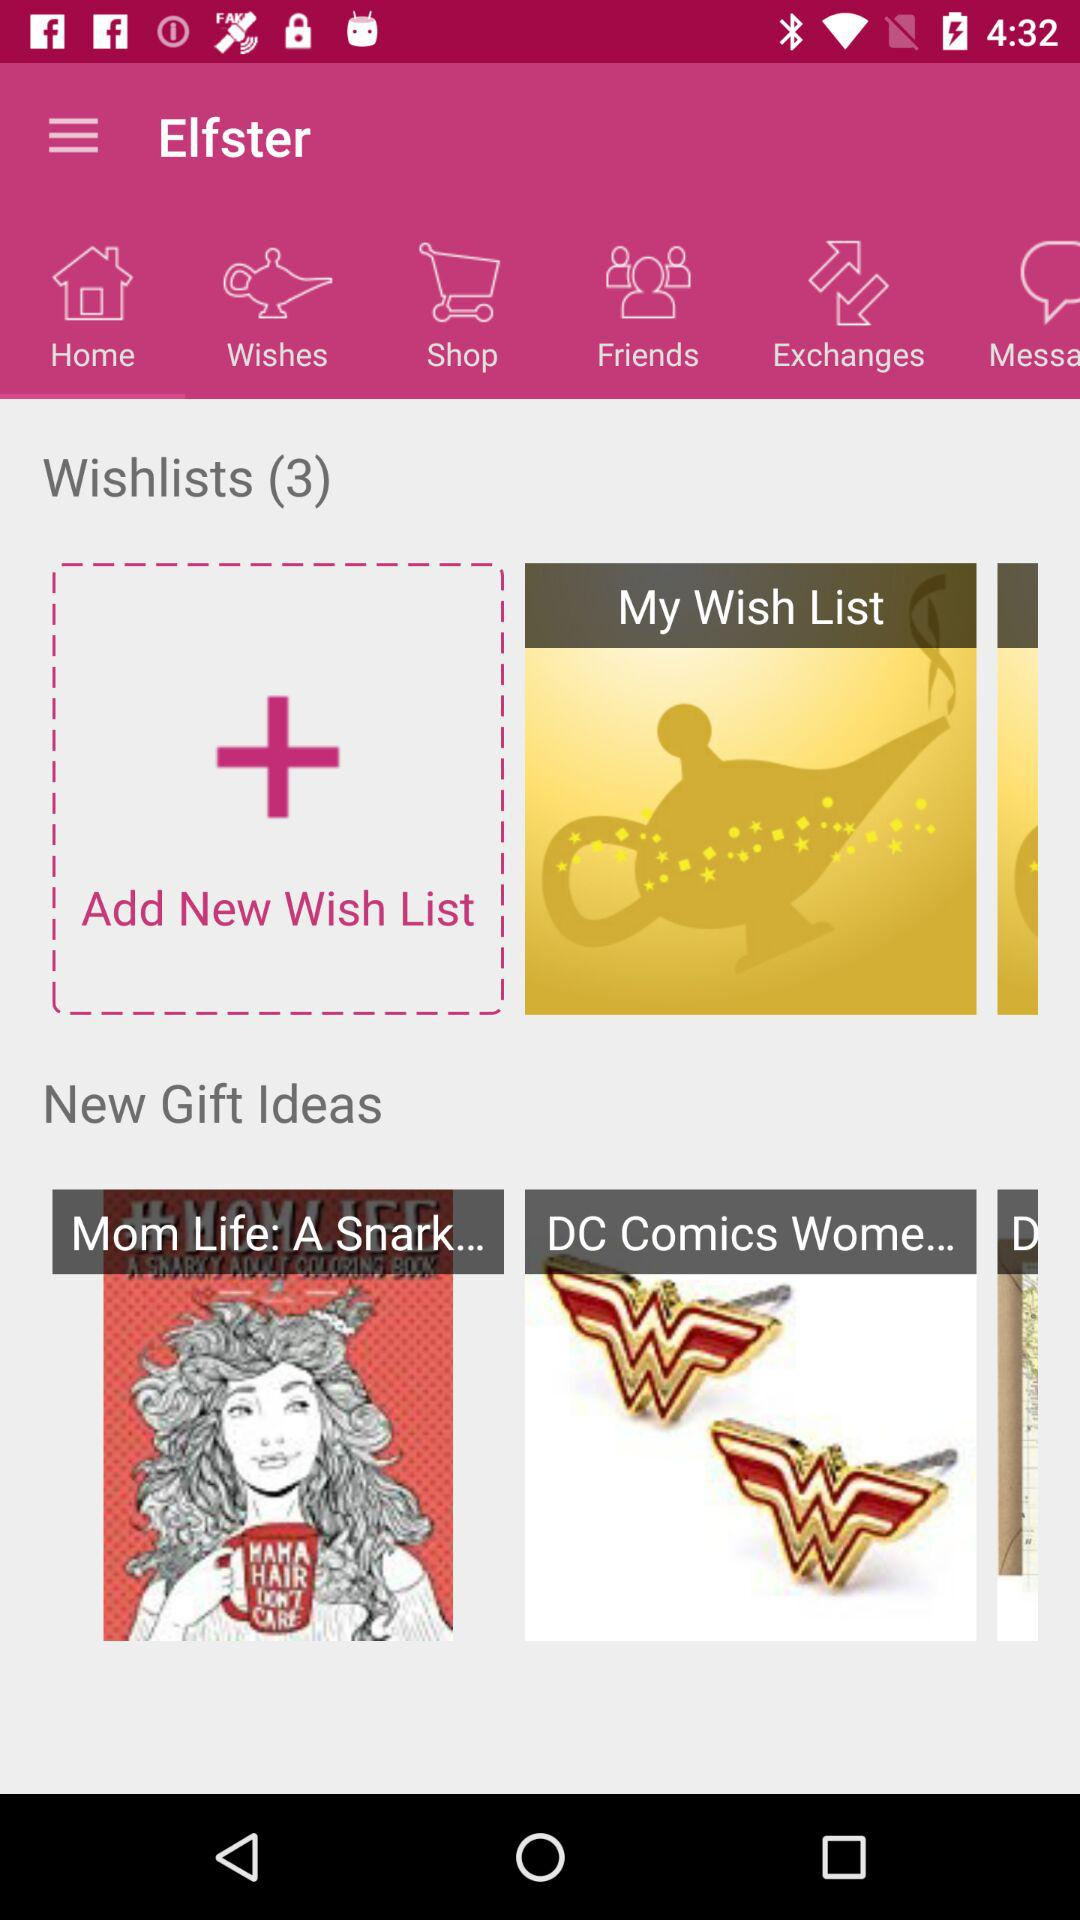Who are the user's friends?
When the provided information is insufficient, respond with <no answer>. <no answer> 